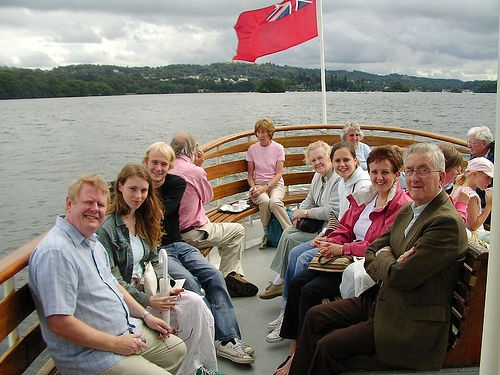Describe the objects in this image and their specific colors. I can see people in darkgray, black, gray, maroon, and brown tones, boat in darkgray, black, gray, and maroon tones, people in darkgray, gray, brown, and lightgray tones, people in darkgray, black, gray, and lightgray tones, and people in darkgray, black, brown, and maroon tones in this image. 